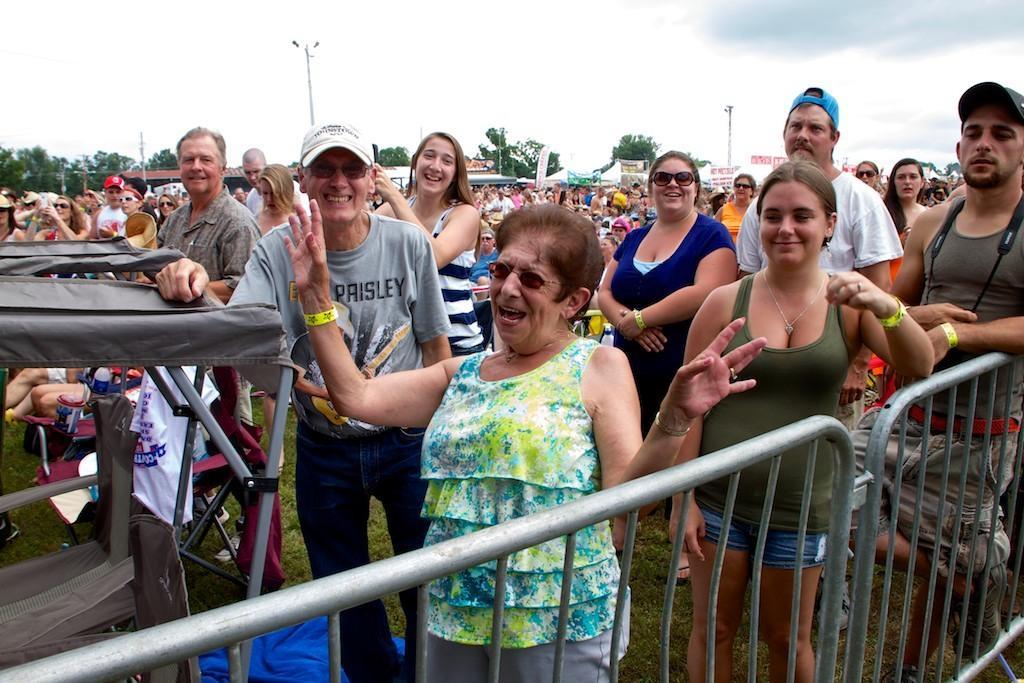How would you summarize this image in a sentence or two? In the image we can see there are lot of people standing on the ground and there's grass on the ground. Behind there are tents and there are lot of trees. The people are wearing yellow colour hand bands in their hand. 